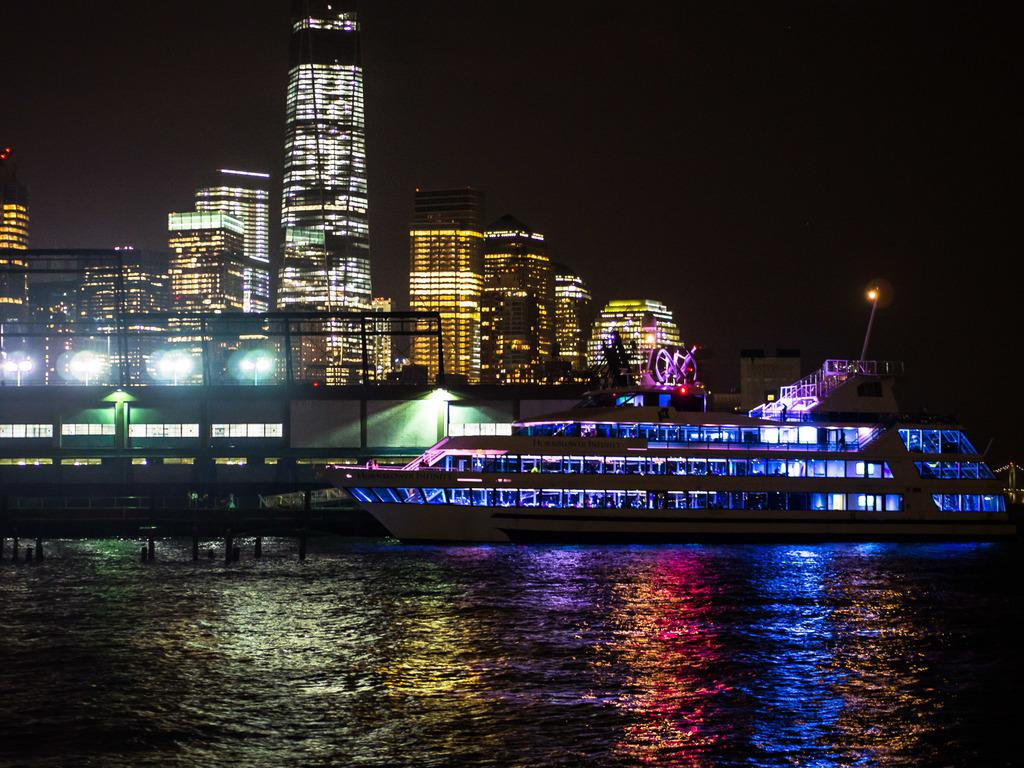What is the main subject of the image? There is a ship in the image. Where is the ship located? The ship is on the water. Are there any other ships visible in the image? Yes, there are additional ships to the right of the main ship. What can be seen in the background of the image? There are buildings and the sky visible in the background of the image. What type of account does the ship have with the bank in the image? There is no indication of a bank or any financial activity in the image; it simply shows a ship on the water with other ships nearby and buildings and the sky in the background. 